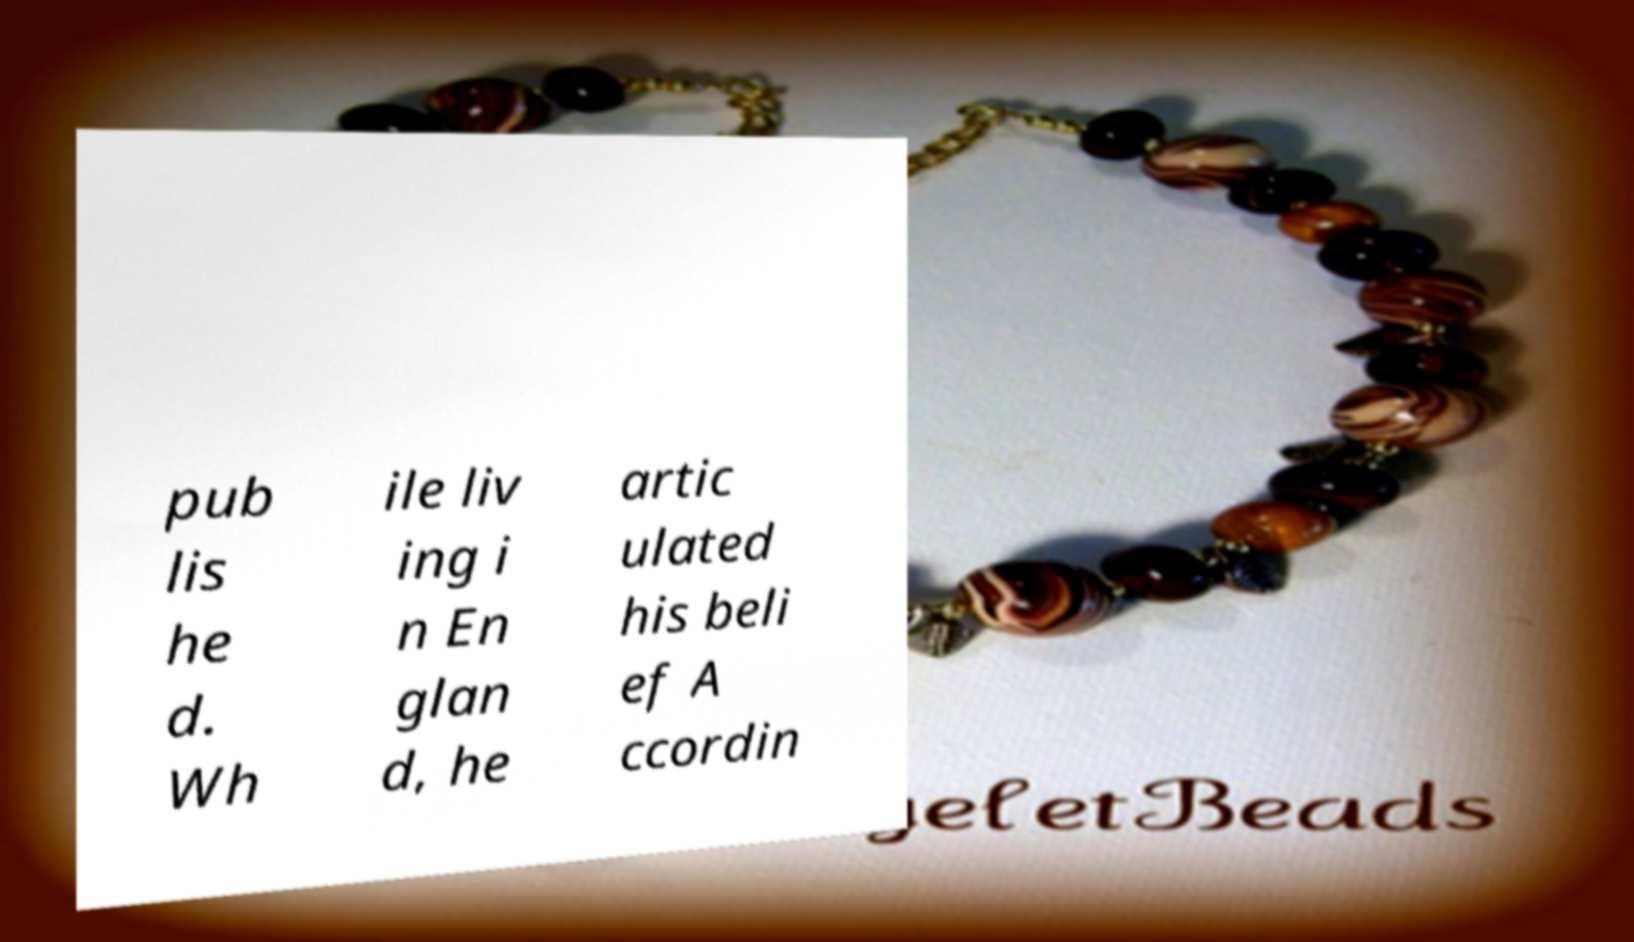Please identify and transcribe the text found in this image. pub lis he d. Wh ile liv ing i n En glan d, he artic ulated his beli ef A ccordin 